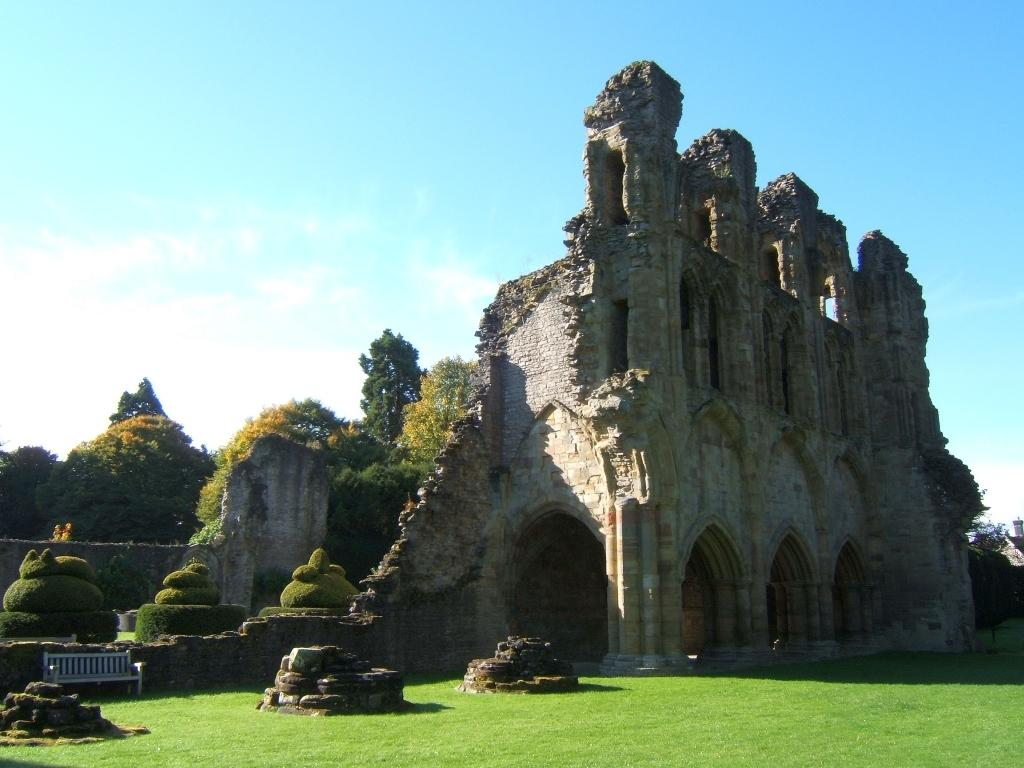What type of structure is in the image? There is an old architecture building in the image. What is located in front of the building? There is a bench in front of the building. Where is the bench situated? The bench is on a grass path. What other elements can be seen in the image? Stones are present in the image, and there are trees behind the building. What can be seen above the building and trees? The sky is visible in the image. What type of gun is being used by the person sitting on the bench in the image? There is no person or gun present in the image; it only features an old architecture building, a bench, a grass path, stones, trees, and the sky. 